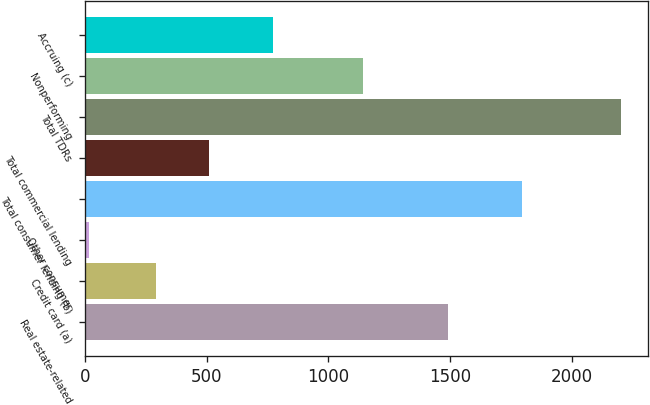Convert chart. <chart><loc_0><loc_0><loc_500><loc_500><bar_chart><fcel>Real estate-related<fcel>Credit card (a)<fcel>Other consumer<fcel>Total consumer lending (b)<fcel>Total commercial lending<fcel>Total TDRs<fcel>Nonperforming<fcel>Accruing (c)<nl><fcel>1492<fcel>291<fcel>15<fcel>1798<fcel>509.8<fcel>2203<fcel>1141<fcel>771<nl></chart> 